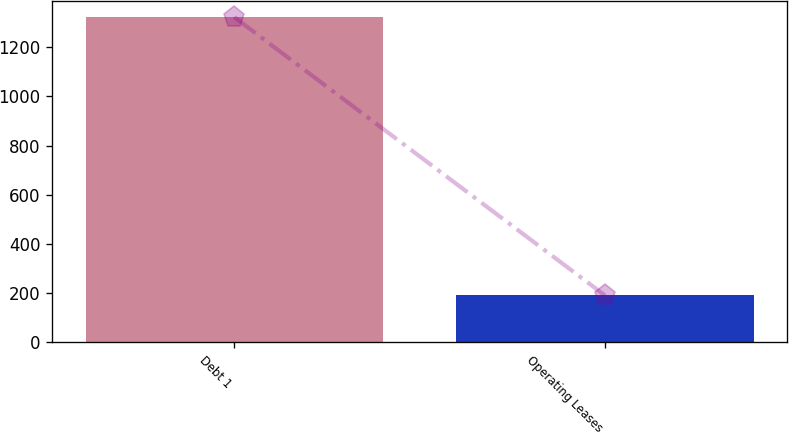<chart> <loc_0><loc_0><loc_500><loc_500><bar_chart><fcel>Debt 1<fcel>Operating Leases<nl><fcel>1322<fcel>191<nl></chart> 